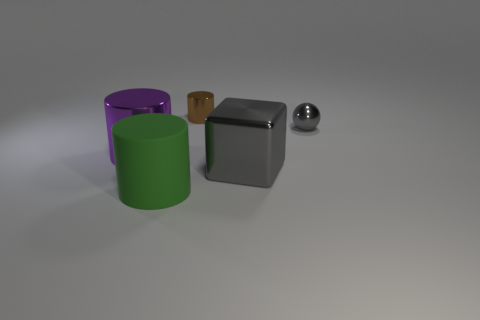Subtract all large cylinders. How many cylinders are left? 1 Add 4 spheres. How many objects exist? 9 Subtract all cylinders. How many objects are left? 2 Add 5 small gray metal balls. How many small gray metal balls are left? 6 Add 4 brown shiny cylinders. How many brown shiny cylinders exist? 5 Subtract 0 blue cylinders. How many objects are left? 5 Subtract all small metal objects. Subtract all small purple matte cylinders. How many objects are left? 3 